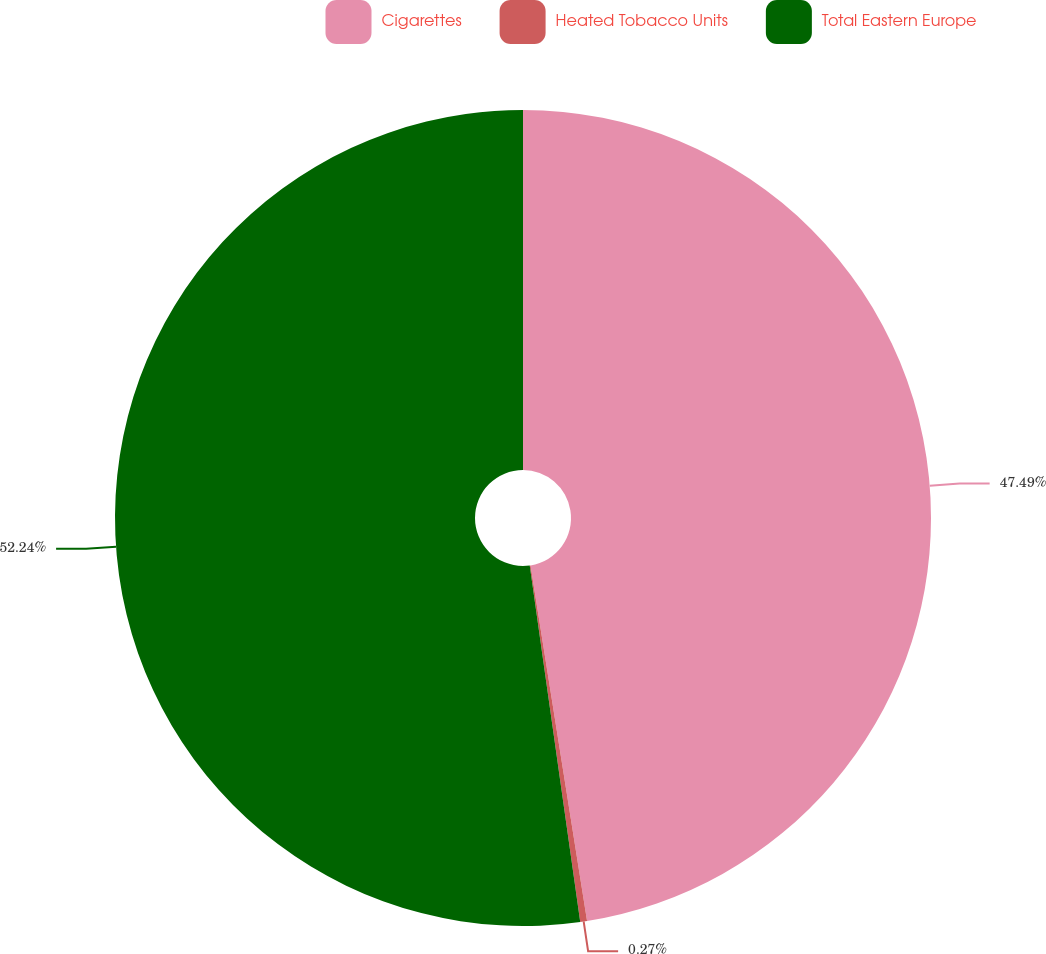Convert chart to OTSL. <chart><loc_0><loc_0><loc_500><loc_500><pie_chart><fcel>Cigarettes<fcel>Heated Tobacco Units<fcel>Total Eastern Europe<nl><fcel>47.49%<fcel>0.27%<fcel>52.24%<nl></chart> 